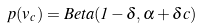Convert formula to latex. <formula><loc_0><loc_0><loc_500><loc_500>p ( v _ { c } ) = B e t a ( 1 - \delta , \alpha + \delta c ) \,</formula> 